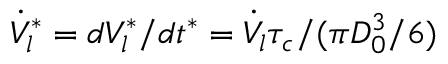<formula> <loc_0><loc_0><loc_500><loc_500>\dot { V } _ { l } ^ { * } = d V _ { l } ^ { * } / d t ^ { * } = \dot { V } _ { l } \tau _ { c } / ( \pi D _ { 0 } ^ { 3 } / 6 )</formula> 